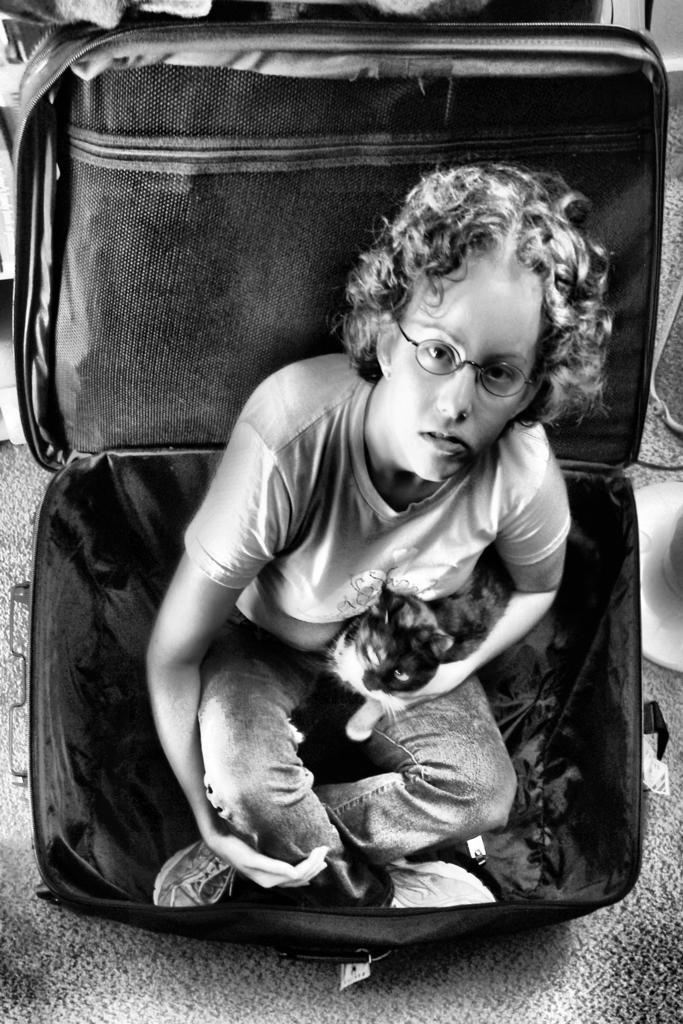Who is the main subject in the image? There is a woman in the image. What is the woman holding in the image? The woman is holding a cat. Where is the woman sitting in the image? The woman is sitting in a suitcase. What type of flooring is visible in the image? There is a carpet in the image. What type of lunch is the woman eating in the image? There is no lunch visible in the image; the woman is holding a cat and sitting in a suitcase. What is the price of the kitten in the image? There is no kitten present in the image; the woman is holding a cat. 